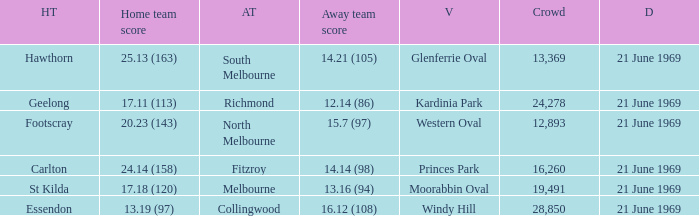When was there a game at Kardinia Park? 21 June 1969. 